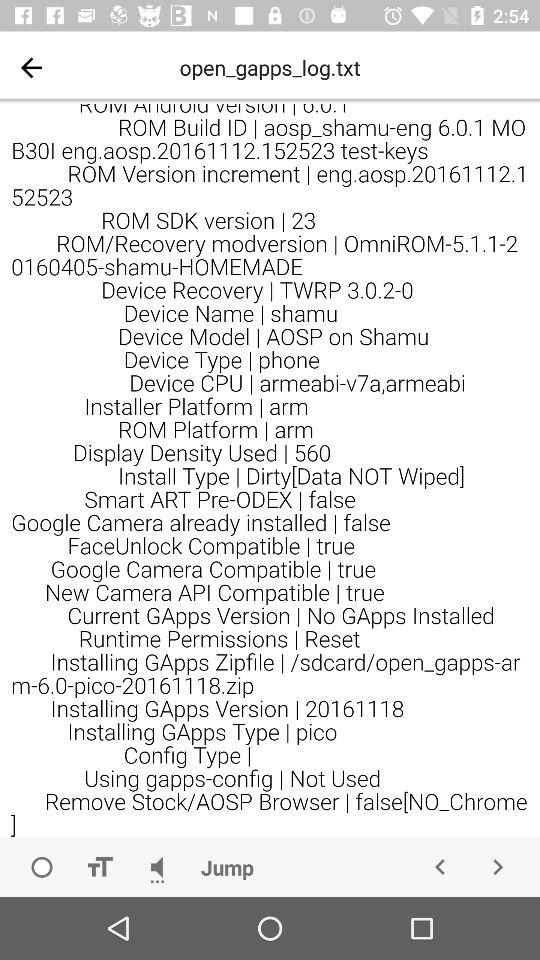What is the version of ROM SDK?
When the provided information is insufficient, respond with <no answer>. <no answer> 